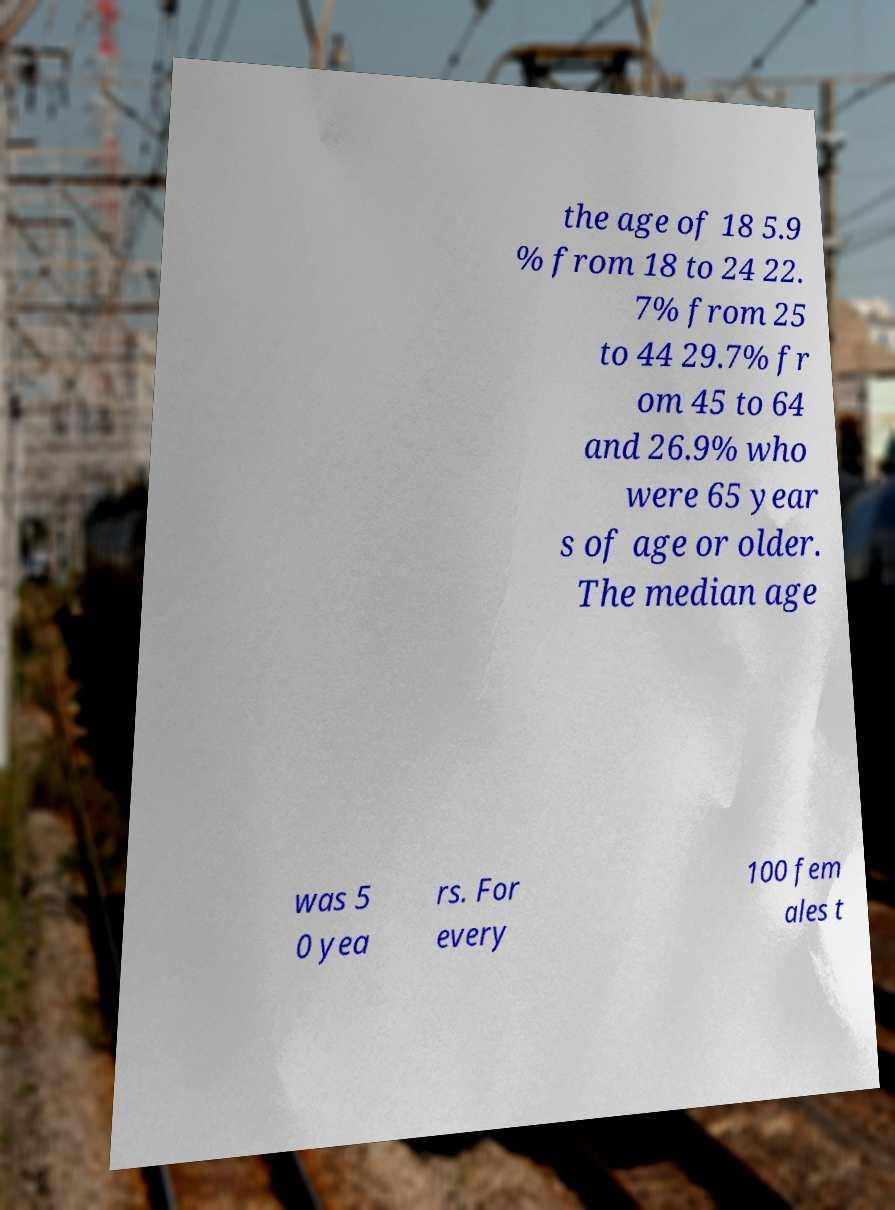Could you assist in decoding the text presented in this image and type it out clearly? the age of 18 5.9 % from 18 to 24 22. 7% from 25 to 44 29.7% fr om 45 to 64 and 26.9% who were 65 year s of age or older. The median age was 5 0 yea rs. For every 100 fem ales t 